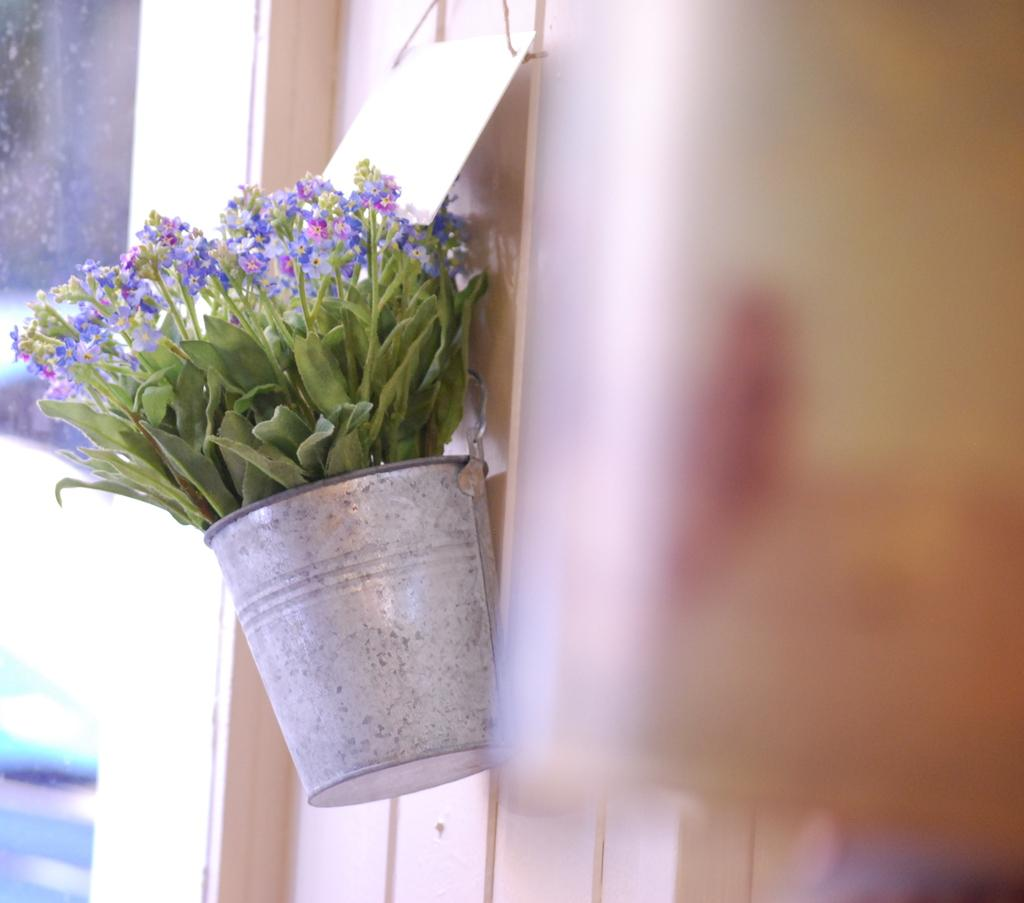What type of plants can be seen in the image? There are flowers and leaves in the image. Can you describe the container for the plants? There is a bucket hanging on the wall in the image. What type of respect can be seen in the image? There is no indication of respect in the image; it features flowers, leaves, and a bucket hanging on the wall. Can you describe the woman in the image? There is no woman present in the image. 